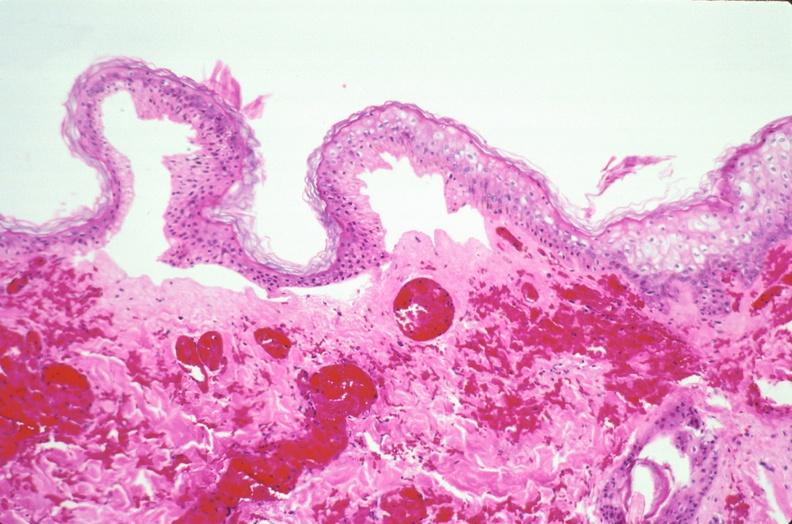where is this?
Answer the question using a single word or phrase. Skin 